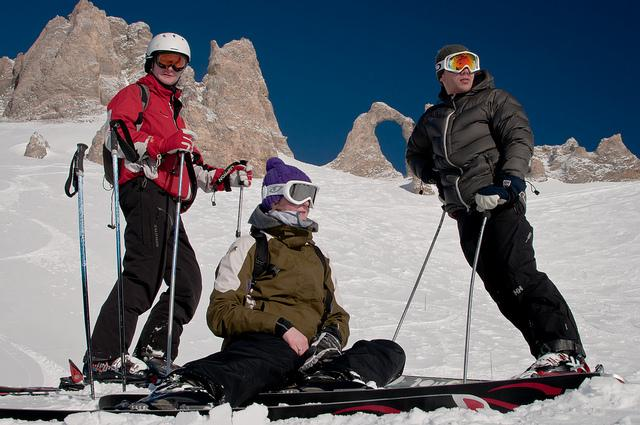What are the poles helping the man on the right do? balance 